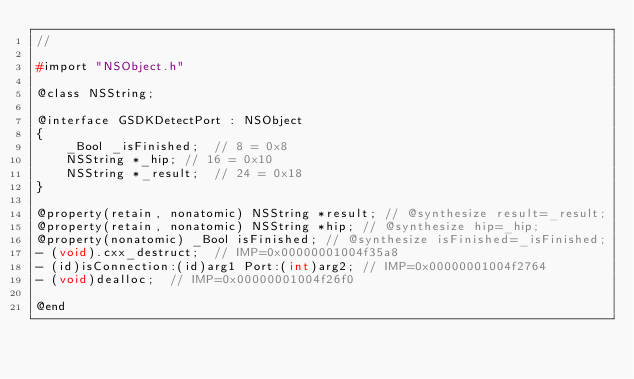<code> <loc_0><loc_0><loc_500><loc_500><_C_>//

#import "NSObject.h"

@class NSString;

@interface GSDKDetectPort : NSObject
{
    _Bool _isFinished;	// 8 = 0x8
    NSString *_hip;	// 16 = 0x10
    NSString *_result;	// 24 = 0x18
}

@property(retain, nonatomic) NSString *result; // @synthesize result=_result;
@property(retain, nonatomic) NSString *hip; // @synthesize hip=_hip;
@property(nonatomic) _Bool isFinished; // @synthesize isFinished=_isFinished;
- (void).cxx_destruct;	// IMP=0x00000001004f35a8
- (id)isConnection:(id)arg1 Port:(int)arg2;	// IMP=0x00000001004f2764
- (void)dealloc;	// IMP=0x00000001004f26f0

@end

</code> 